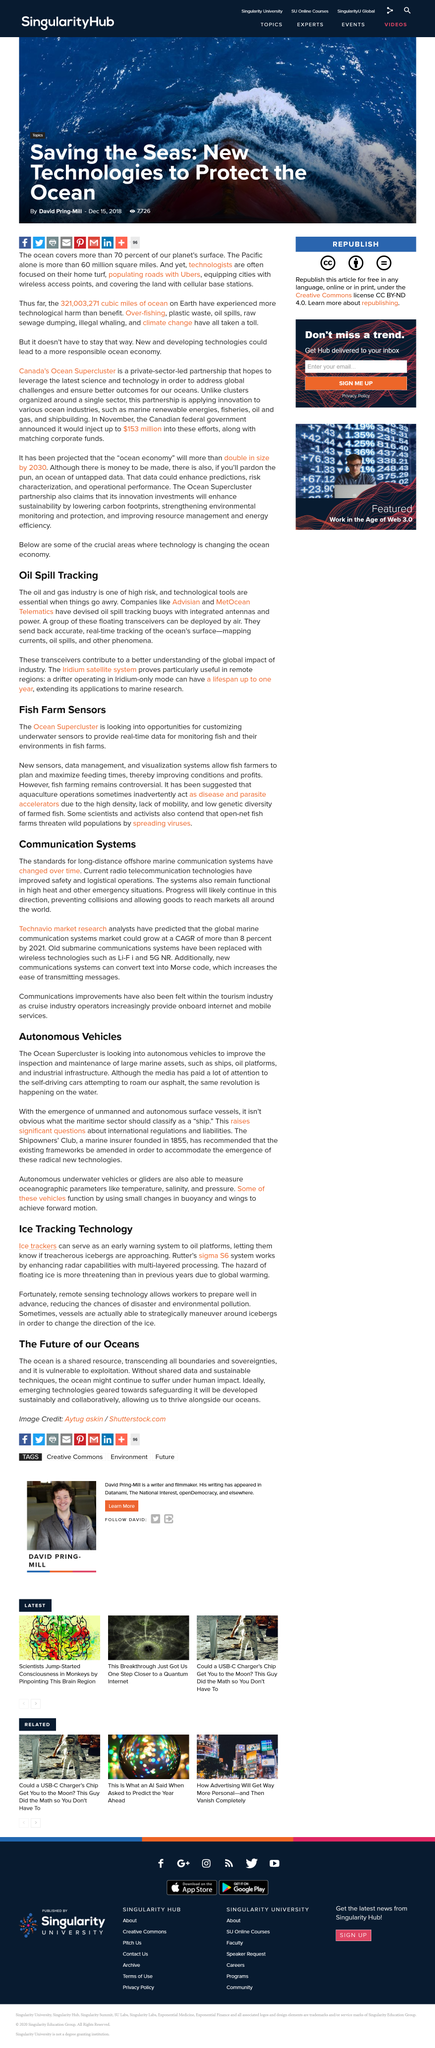Identify some key points in this picture. Rutter's system is a multi-layered processing technology that enhances radar capabilities. The name of this system is Sigma S6. The Ocean Supercluster aims to advance the development and deployment of autonomous vehicles to enhance the inspection and maintenance of marine assets, thereby improving the efficiency and safety of marine operations. Some scientists and activists argue that open-net fish farms pose a threat to wild populations by spreading viruses. Ice trackers effectively reduce the chances of environmental pollution. The oil spill tracking buoys are designed to accurately relay real-time tracking data of the ocean's surface, including current information and the location of oil spills, as well as other phenomena. 